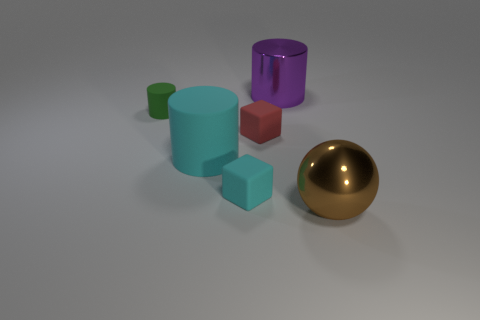There is a big object that is right of the cyan cylinder and in front of the metal cylinder; what is its shape?
Your answer should be very brief. Sphere. What number of cyan objects have the same shape as the brown metal object?
Offer a terse response. 0. What number of matte cylinders are there?
Your answer should be compact. 2. How big is the object that is both to the left of the tiny cyan rubber thing and behind the big cyan matte cylinder?
Give a very brief answer. Small. The red matte object that is the same size as the green matte thing is what shape?
Your response must be concise. Cube. Is there a big purple object in front of the big cylinder on the left side of the tiny red rubber block?
Offer a terse response. No. What is the color of the other matte object that is the same shape as the small cyan matte thing?
Keep it short and to the point. Red. Do the cube on the left side of the tiny red matte object and the large metallic cylinder have the same color?
Offer a very short reply. No. What number of objects are cylinders that are behind the green object or tiny things?
Offer a terse response. 4. The big cylinder behind the large object on the left side of the large object behind the small green rubber thing is made of what material?
Offer a very short reply. Metal. 